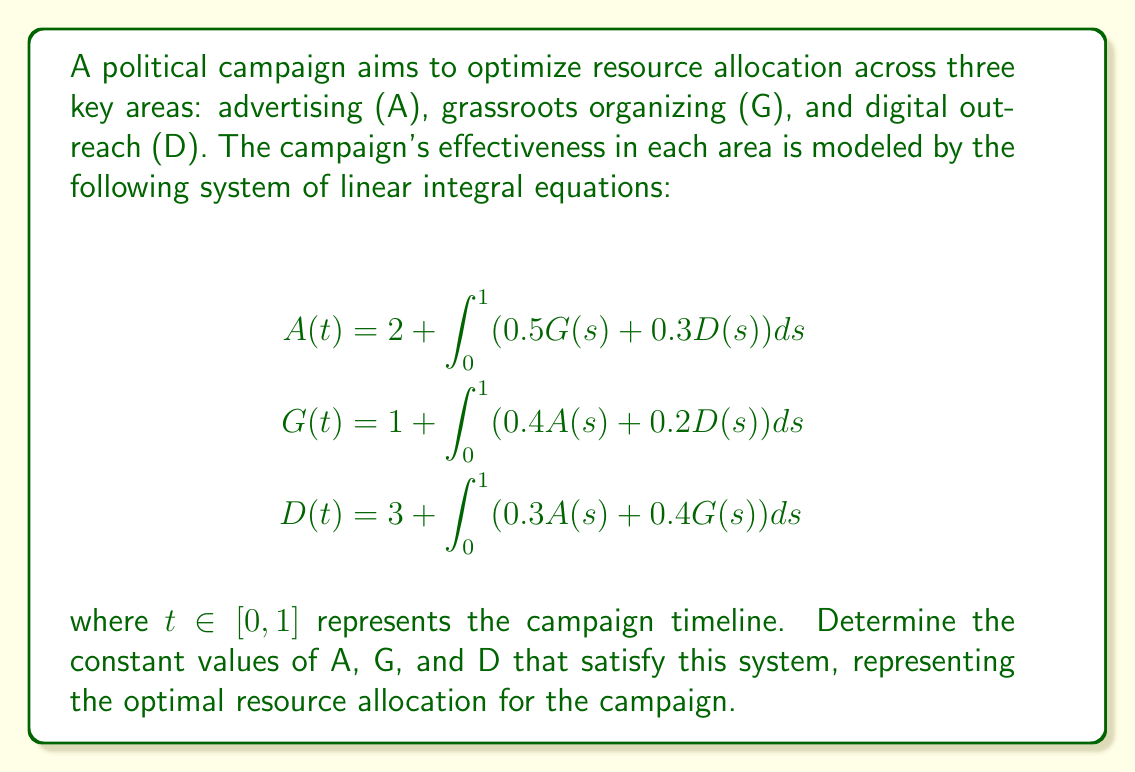Give your solution to this math problem. To solve this system of linear integral equations:

1) First, observe that the right-hand side of each equation doesn't depend on $t$, so A, G, and D must be constant functions.

2) Let's denote these constant values as $a$, $g$, and $d$ respectively.

3) Substituting these into the system:

   $$\begin{align*}
   a &= 2 + \int_0^1 (0.5g + 0.3d) ds \\
   g &= 1 + \int_0^1 (0.4a + 0.2d) ds \\
   d &= 3 + \int_0^1 (0.3a + 0.4g) ds
   \end{align*}$$

4) Evaluating the integrals:

   $$\begin{align*}
   a &= 2 + 0.5g + 0.3d \\
   g &= 1 + 0.4a + 0.2d \\
   d &= 3 + 0.3a + 0.4g
   \end{align*}$$

5) Now we have a system of linear equations. Let's solve it using substitution:

   From the first equation: $a = 2 + 0.5g + 0.3d$
   
   Substitute this into the second equation:
   $g = 1 + 0.4(2 + 0.5g + 0.3d) + 0.2d$
   $g = 1 + 0.8 + 0.2g + 0.12d + 0.2d$
   $0.8g = 1.8 + 0.32d$
   $g = 2.25 + 0.4d$

6) Substitute both $a$ and $g$ into the third equation:
   $d = 3 + 0.3(2 + 0.5g + 0.3d) + 0.4g$
   $d = 3 + 0.6 + 0.15g + 0.09d + 0.4g$
   $d = 3.6 + 0.55g + 0.09d$
   $0.91d = 3.6 + 0.55g$

7) Now substitute $g = 2.25 + 0.4d$ into this equation:
   $0.91d = 3.6 + 0.55(2.25 + 0.4d)$
   $0.91d = 3.6 + 1.2375 + 0.22d$
   $0.69d = 4.8375$
   $d = 7$

8) Now we can find $g$ and $a$:
   $g = 2.25 + 0.4(7) = 5$
   $a = 2 + 0.5(5) + 0.3(7) = 6.6$

Therefore, the optimal resource allocation is:
A (advertising) = 6.6
G (grassroots organizing) = 5
D (digital outreach) = 7
Answer: A = 6.6, G = 5, D = 7 